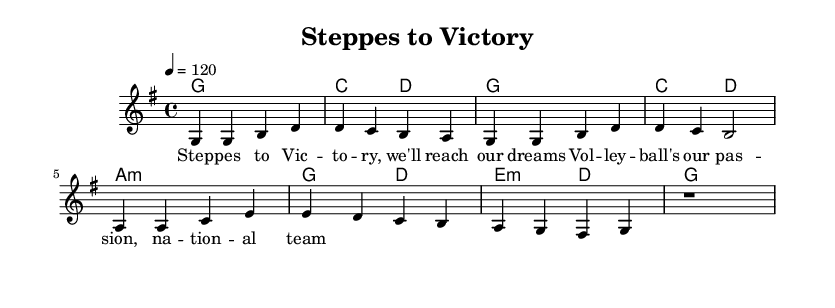What is the key signature of this music? The key signature is indicated by the presence of one sharp. In this case, the G major scale has one sharp (F#).
Answer: G major What is the time signature of this piece? The time signature appears at the beginning of the score, represented with the numbers "4/4". This indicates that there are four beats in a measure, and the quarter note gets one beat.
Answer: 4/4 What is the tempo marking of the piece? The tempo marking is located above the staff and states "4 = 120". This means that there are 120 beats per minute, and the quarter note is the unit of measure for this timing.
Answer: 120 How many measures are in the melody? To determine the number of measures, you can count the groups of notes separated by bar lines in the melody section. In this case, there are a total of eight measures.
Answer: 8 What is the last note of the melody? The last note in the melody is indicated in the final measure of the sheet music, which shows a rest, meaning the concluding sound is a pause rather than a specific note.
Answer: Rest What chord follows the note A4 in the harmonies? The chord progression immediately following the A4 note in the harmony part shows that the chord is G major after A minor. You can infer this by looking at the chord mode's context surrounding the measured bars.
Answer: G major What is the primary theme of the lyrics? By examining the lyrics, they express a sentiment about aspirations related to volleyball and the dream of being part of a national team, indicating the theme of pursuing dreams in sports.
Answer: Pursuing dreams 